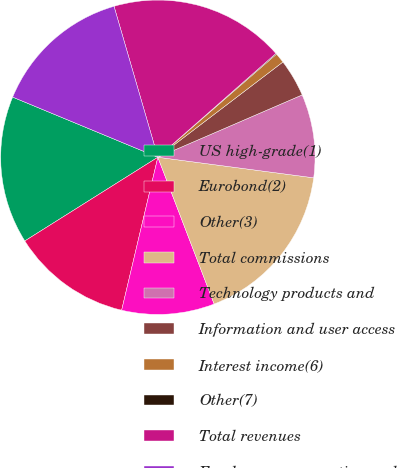Convert chart. <chart><loc_0><loc_0><loc_500><loc_500><pie_chart><fcel>US high-grade(1)<fcel>Eurobond(2)<fcel>Other(3)<fcel>Total commissions<fcel>Technology products and<fcel>Information and user access<fcel>Interest income(6)<fcel>Other(7)<fcel>Total revenues<fcel>Employee compensation and<nl><fcel>15.19%<fcel>12.36%<fcel>9.53%<fcel>17.08%<fcel>8.58%<fcel>3.87%<fcel>1.03%<fcel>0.09%<fcel>18.02%<fcel>14.25%<nl></chart> 